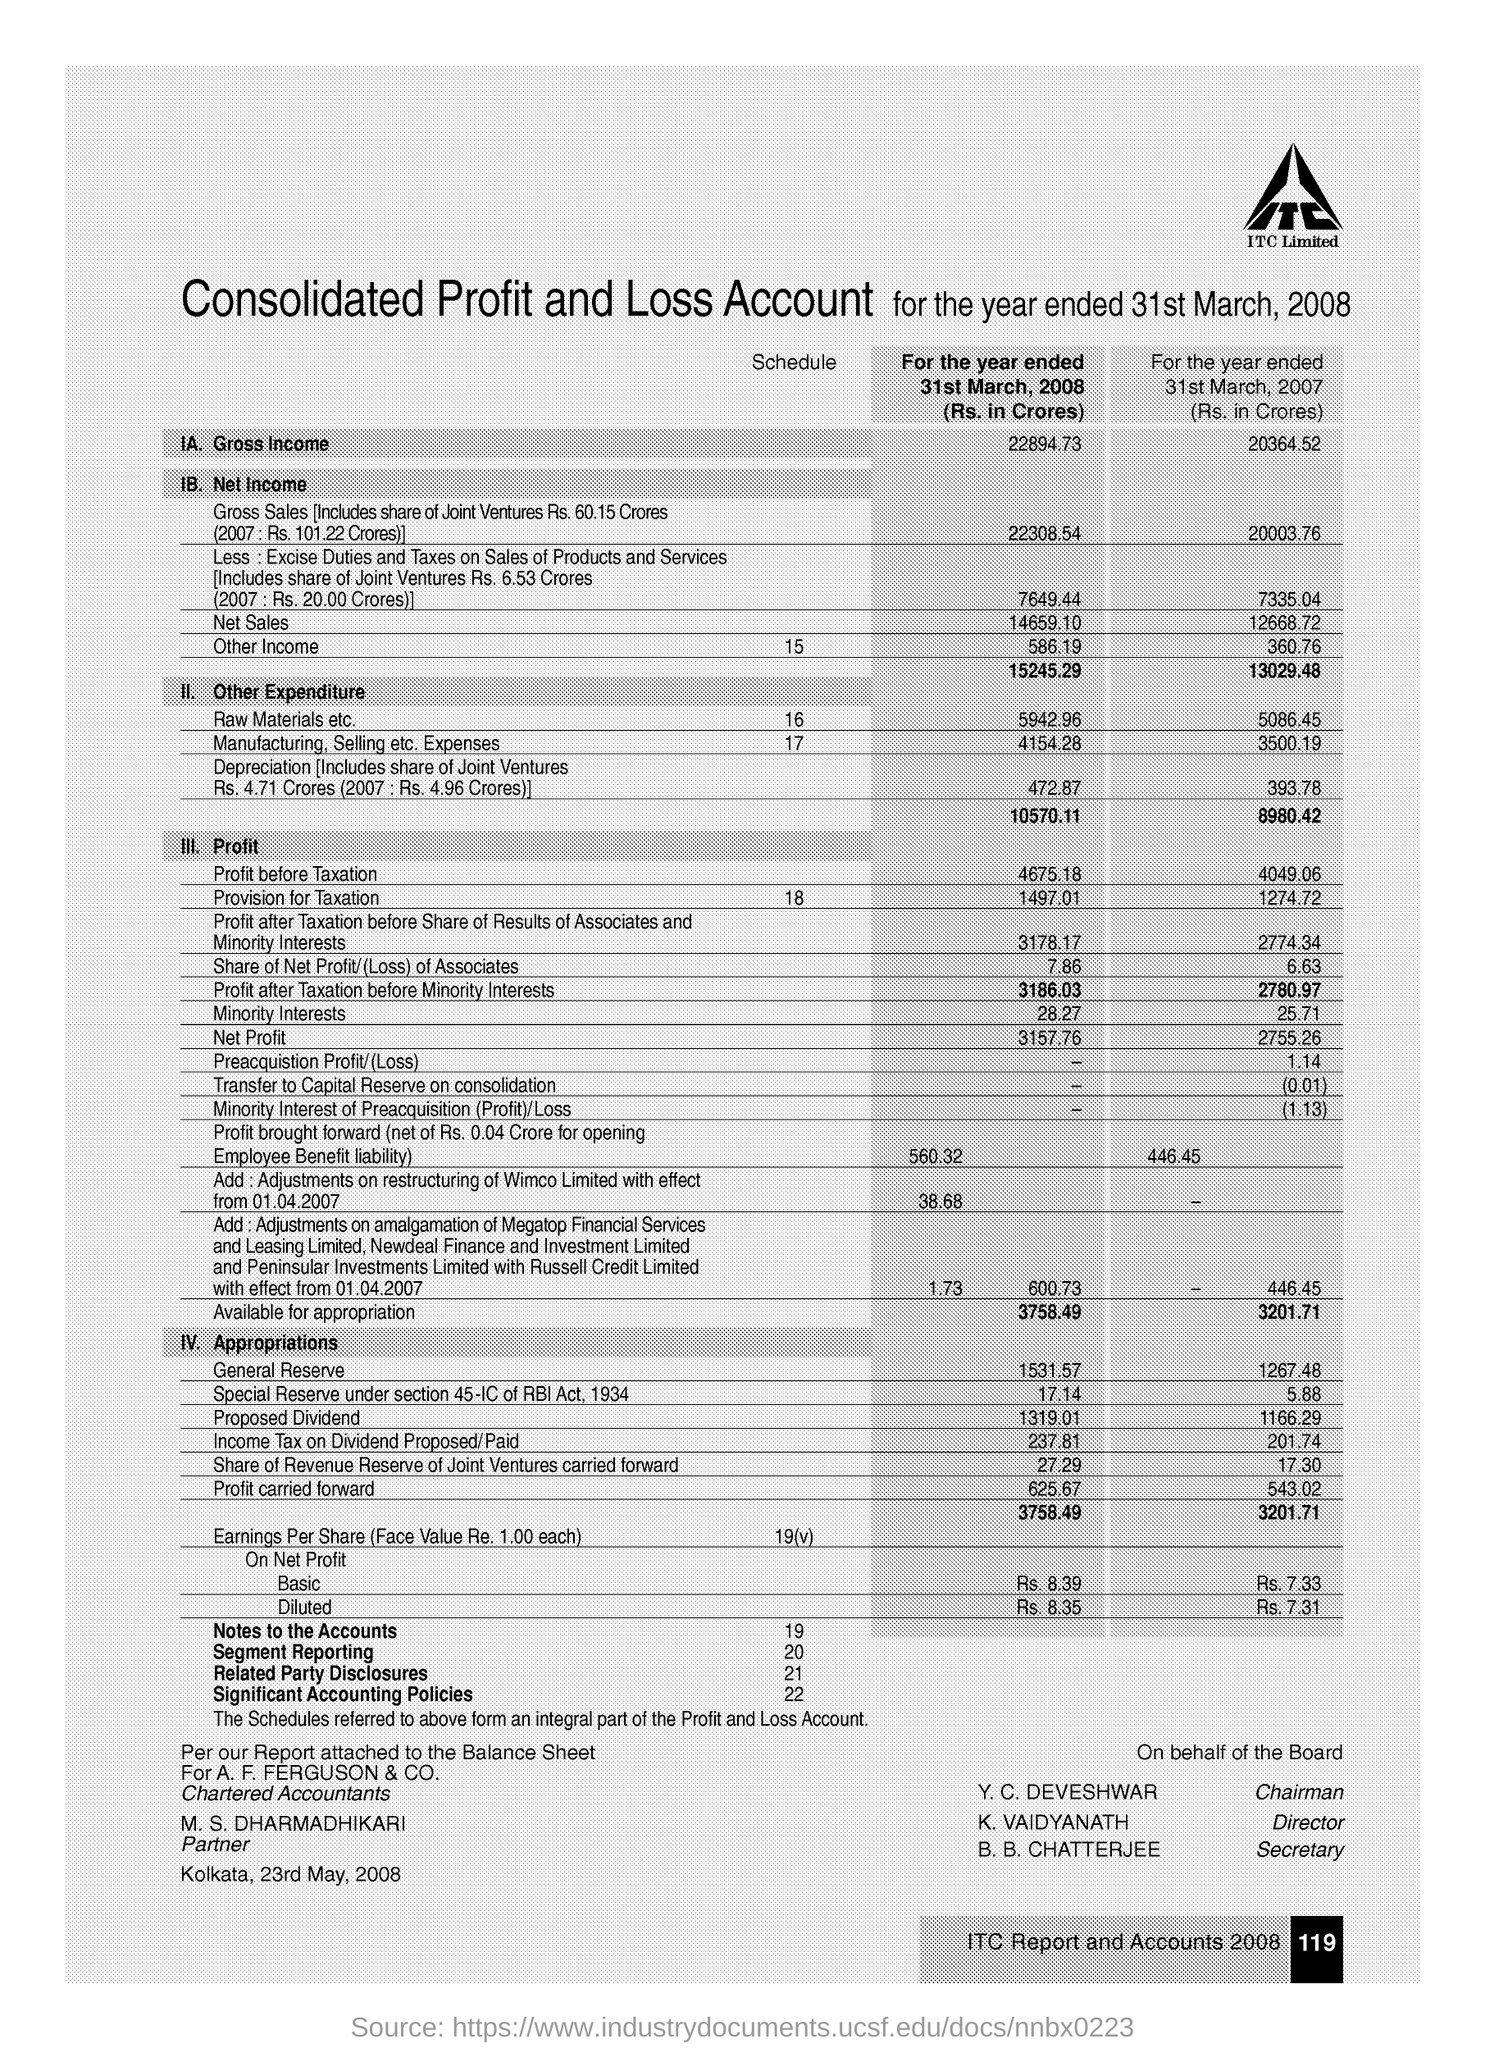Highlight a few significant elements in this photo. The gross income for the year ended March 31, 2008, was 22,894.73. The "profit before taxation" for the year ended March 31, 2008 was 4,675.18. The total net income for the year ended March 31, 2007 was 13,029.48. The Director is K VAIDYANATH. 